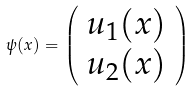<formula> <loc_0><loc_0><loc_500><loc_500>\psi ( x ) = \left ( \begin{array} { c } u _ { 1 } ( x ) \\ u _ { 2 } ( x ) \end{array} \right )</formula> 